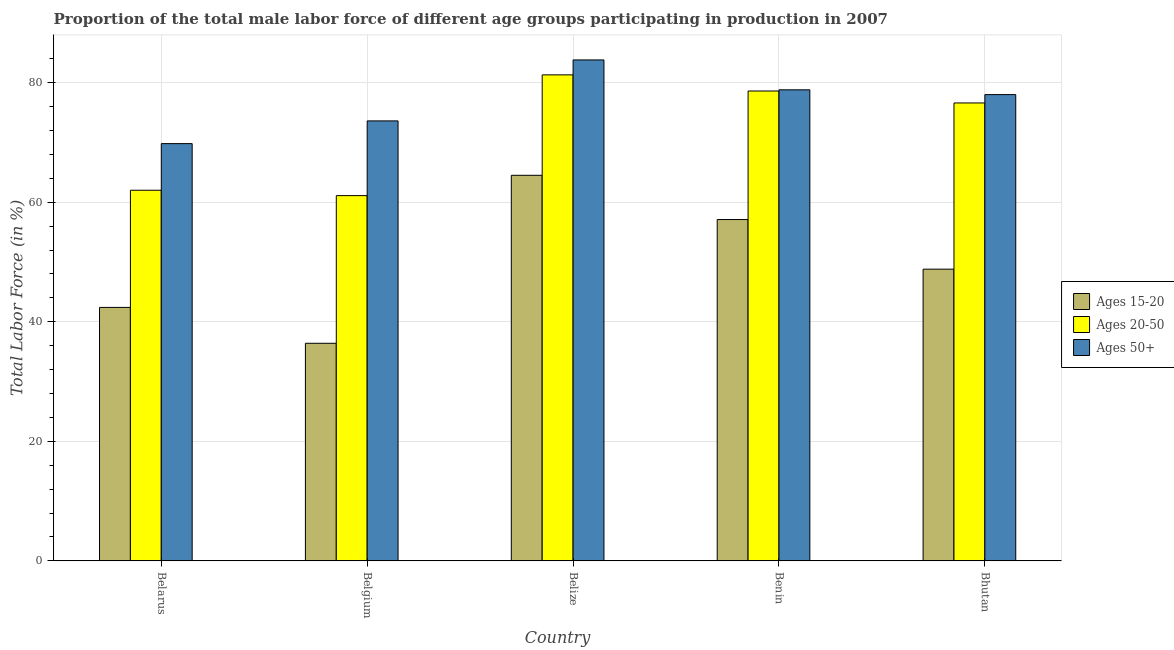How many groups of bars are there?
Ensure brevity in your answer.  5. Are the number of bars per tick equal to the number of legend labels?
Keep it short and to the point. Yes. Are the number of bars on each tick of the X-axis equal?
Your answer should be compact. Yes. How many bars are there on the 1st tick from the left?
Your response must be concise. 3. How many bars are there on the 1st tick from the right?
Make the answer very short. 3. What is the label of the 1st group of bars from the left?
Offer a very short reply. Belarus. What is the percentage of male labor force within the age group 20-50 in Belize?
Offer a terse response. 81.3. Across all countries, what is the maximum percentage of male labor force above age 50?
Offer a very short reply. 83.8. Across all countries, what is the minimum percentage of male labor force within the age group 20-50?
Offer a very short reply. 61.1. In which country was the percentage of male labor force above age 50 maximum?
Ensure brevity in your answer.  Belize. In which country was the percentage of male labor force above age 50 minimum?
Your answer should be compact. Belarus. What is the total percentage of male labor force above age 50 in the graph?
Make the answer very short. 384. What is the difference between the percentage of male labor force within the age group 15-20 in Belarus and that in Belgium?
Make the answer very short. 6. What is the difference between the percentage of male labor force within the age group 15-20 in Belgium and the percentage of male labor force within the age group 20-50 in Bhutan?
Give a very brief answer. -40.2. What is the average percentage of male labor force within the age group 20-50 per country?
Your answer should be very brief. 71.92. What is the difference between the percentage of male labor force within the age group 20-50 and percentage of male labor force above age 50 in Belgium?
Make the answer very short. -12.5. In how many countries, is the percentage of male labor force within the age group 20-50 greater than 80 %?
Give a very brief answer. 1. What is the ratio of the percentage of male labor force within the age group 20-50 in Benin to that in Bhutan?
Your answer should be very brief. 1.03. Is the percentage of male labor force within the age group 15-20 in Belgium less than that in Bhutan?
Offer a terse response. Yes. Is the difference between the percentage of male labor force above age 50 in Belarus and Bhutan greater than the difference between the percentage of male labor force within the age group 15-20 in Belarus and Bhutan?
Give a very brief answer. No. What is the difference between the highest and the second highest percentage of male labor force above age 50?
Your response must be concise. 5. What is the difference between the highest and the lowest percentage of male labor force within the age group 15-20?
Your answer should be compact. 28.1. In how many countries, is the percentage of male labor force above age 50 greater than the average percentage of male labor force above age 50 taken over all countries?
Your answer should be compact. 3. What does the 3rd bar from the left in Bhutan represents?
Give a very brief answer. Ages 50+. What does the 1st bar from the right in Bhutan represents?
Provide a short and direct response. Ages 50+. Is it the case that in every country, the sum of the percentage of male labor force within the age group 15-20 and percentage of male labor force within the age group 20-50 is greater than the percentage of male labor force above age 50?
Your answer should be very brief. Yes. How many bars are there?
Your answer should be very brief. 15. What is the difference between two consecutive major ticks on the Y-axis?
Give a very brief answer. 20. Does the graph contain any zero values?
Ensure brevity in your answer.  No. Does the graph contain grids?
Offer a very short reply. Yes. How many legend labels are there?
Make the answer very short. 3. How are the legend labels stacked?
Your answer should be very brief. Vertical. What is the title of the graph?
Keep it short and to the point. Proportion of the total male labor force of different age groups participating in production in 2007. What is the label or title of the X-axis?
Offer a terse response. Country. What is the label or title of the Y-axis?
Provide a short and direct response. Total Labor Force (in %). What is the Total Labor Force (in %) in Ages 15-20 in Belarus?
Provide a succinct answer. 42.4. What is the Total Labor Force (in %) in Ages 50+ in Belarus?
Provide a succinct answer. 69.8. What is the Total Labor Force (in %) of Ages 15-20 in Belgium?
Your answer should be very brief. 36.4. What is the Total Labor Force (in %) of Ages 20-50 in Belgium?
Provide a short and direct response. 61.1. What is the Total Labor Force (in %) of Ages 50+ in Belgium?
Make the answer very short. 73.6. What is the Total Labor Force (in %) in Ages 15-20 in Belize?
Ensure brevity in your answer.  64.5. What is the Total Labor Force (in %) in Ages 20-50 in Belize?
Your answer should be compact. 81.3. What is the Total Labor Force (in %) of Ages 50+ in Belize?
Offer a very short reply. 83.8. What is the Total Labor Force (in %) of Ages 15-20 in Benin?
Give a very brief answer. 57.1. What is the Total Labor Force (in %) of Ages 20-50 in Benin?
Offer a terse response. 78.6. What is the Total Labor Force (in %) of Ages 50+ in Benin?
Offer a terse response. 78.8. What is the Total Labor Force (in %) in Ages 15-20 in Bhutan?
Provide a succinct answer. 48.8. What is the Total Labor Force (in %) in Ages 20-50 in Bhutan?
Make the answer very short. 76.6. What is the Total Labor Force (in %) in Ages 50+ in Bhutan?
Give a very brief answer. 78. Across all countries, what is the maximum Total Labor Force (in %) in Ages 15-20?
Offer a very short reply. 64.5. Across all countries, what is the maximum Total Labor Force (in %) of Ages 20-50?
Your answer should be very brief. 81.3. Across all countries, what is the maximum Total Labor Force (in %) of Ages 50+?
Make the answer very short. 83.8. Across all countries, what is the minimum Total Labor Force (in %) in Ages 15-20?
Provide a short and direct response. 36.4. Across all countries, what is the minimum Total Labor Force (in %) in Ages 20-50?
Provide a short and direct response. 61.1. Across all countries, what is the minimum Total Labor Force (in %) of Ages 50+?
Give a very brief answer. 69.8. What is the total Total Labor Force (in %) in Ages 15-20 in the graph?
Give a very brief answer. 249.2. What is the total Total Labor Force (in %) of Ages 20-50 in the graph?
Offer a very short reply. 359.6. What is the total Total Labor Force (in %) of Ages 50+ in the graph?
Make the answer very short. 384. What is the difference between the Total Labor Force (in %) in Ages 15-20 in Belarus and that in Belgium?
Ensure brevity in your answer.  6. What is the difference between the Total Labor Force (in %) of Ages 50+ in Belarus and that in Belgium?
Your answer should be compact. -3.8. What is the difference between the Total Labor Force (in %) in Ages 15-20 in Belarus and that in Belize?
Give a very brief answer. -22.1. What is the difference between the Total Labor Force (in %) in Ages 20-50 in Belarus and that in Belize?
Offer a terse response. -19.3. What is the difference between the Total Labor Force (in %) in Ages 50+ in Belarus and that in Belize?
Make the answer very short. -14. What is the difference between the Total Labor Force (in %) in Ages 15-20 in Belarus and that in Benin?
Give a very brief answer. -14.7. What is the difference between the Total Labor Force (in %) of Ages 20-50 in Belarus and that in Benin?
Give a very brief answer. -16.6. What is the difference between the Total Labor Force (in %) of Ages 15-20 in Belarus and that in Bhutan?
Provide a short and direct response. -6.4. What is the difference between the Total Labor Force (in %) in Ages 20-50 in Belarus and that in Bhutan?
Keep it short and to the point. -14.6. What is the difference between the Total Labor Force (in %) in Ages 50+ in Belarus and that in Bhutan?
Offer a terse response. -8.2. What is the difference between the Total Labor Force (in %) of Ages 15-20 in Belgium and that in Belize?
Your answer should be compact. -28.1. What is the difference between the Total Labor Force (in %) of Ages 20-50 in Belgium and that in Belize?
Your answer should be compact. -20.2. What is the difference between the Total Labor Force (in %) in Ages 50+ in Belgium and that in Belize?
Give a very brief answer. -10.2. What is the difference between the Total Labor Force (in %) in Ages 15-20 in Belgium and that in Benin?
Offer a terse response. -20.7. What is the difference between the Total Labor Force (in %) of Ages 20-50 in Belgium and that in Benin?
Offer a very short reply. -17.5. What is the difference between the Total Labor Force (in %) in Ages 50+ in Belgium and that in Benin?
Provide a short and direct response. -5.2. What is the difference between the Total Labor Force (in %) of Ages 15-20 in Belgium and that in Bhutan?
Your answer should be compact. -12.4. What is the difference between the Total Labor Force (in %) in Ages 20-50 in Belgium and that in Bhutan?
Your answer should be very brief. -15.5. What is the difference between the Total Labor Force (in %) in Ages 15-20 in Belize and that in Benin?
Make the answer very short. 7.4. What is the difference between the Total Labor Force (in %) of Ages 50+ in Belize and that in Benin?
Your answer should be very brief. 5. What is the difference between the Total Labor Force (in %) of Ages 20-50 in Belize and that in Bhutan?
Offer a terse response. 4.7. What is the difference between the Total Labor Force (in %) of Ages 50+ in Belize and that in Bhutan?
Offer a very short reply. 5.8. What is the difference between the Total Labor Force (in %) in Ages 15-20 in Benin and that in Bhutan?
Provide a succinct answer. 8.3. What is the difference between the Total Labor Force (in %) of Ages 50+ in Benin and that in Bhutan?
Ensure brevity in your answer.  0.8. What is the difference between the Total Labor Force (in %) in Ages 15-20 in Belarus and the Total Labor Force (in %) in Ages 20-50 in Belgium?
Ensure brevity in your answer.  -18.7. What is the difference between the Total Labor Force (in %) of Ages 15-20 in Belarus and the Total Labor Force (in %) of Ages 50+ in Belgium?
Ensure brevity in your answer.  -31.2. What is the difference between the Total Labor Force (in %) of Ages 15-20 in Belarus and the Total Labor Force (in %) of Ages 20-50 in Belize?
Your response must be concise. -38.9. What is the difference between the Total Labor Force (in %) of Ages 15-20 in Belarus and the Total Labor Force (in %) of Ages 50+ in Belize?
Provide a short and direct response. -41.4. What is the difference between the Total Labor Force (in %) of Ages 20-50 in Belarus and the Total Labor Force (in %) of Ages 50+ in Belize?
Your answer should be very brief. -21.8. What is the difference between the Total Labor Force (in %) in Ages 15-20 in Belarus and the Total Labor Force (in %) in Ages 20-50 in Benin?
Your answer should be very brief. -36.2. What is the difference between the Total Labor Force (in %) of Ages 15-20 in Belarus and the Total Labor Force (in %) of Ages 50+ in Benin?
Provide a succinct answer. -36.4. What is the difference between the Total Labor Force (in %) in Ages 20-50 in Belarus and the Total Labor Force (in %) in Ages 50+ in Benin?
Offer a very short reply. -16.8. What is the difference between the Total Labor Force (in %) of Ages 15-20 in Belarus and the Total Labor Force (in %) of Ages 20-50 in Bhutan?
Ensure brevity in your answer.  -34.2. What is the difference between the Total Labor Force (in %) of Ages 15-20 in Belarus and the Total Labor Force (in %) of Ages 50+ in Bhutan?
Provide a succinct answer. -35.6. What is the difference between the Total Labor Force (in %) of Ages 20-50 in Belarus and the Total Labor Force (in %) of Ages 50+ in Bhutan?
Keep it short and to the point. -16. What is the difference between the Total Labor Force (in %) of Ages 15-20 in Belgium and the Total Labor Force (in %) of Ages 20-50 in Belize?
Keep it short and to the point. -44.9. What is the difference between the Total Labor Force (in %) of Ages 15-20 in Belgium and the Total Labor Force (in %) of Ages 50+ in Belize?
Offer a very short reply. -47.4. What is the difference between the Total Labor Force (in %) of Ages 20-50 in Belgium and the Total Labor Force (in %) of Ages 50+ in Belize?
Your response must be concise. -22.7. What is the difference between the Total Labor Force (in %) in Ages 15-20 in Belgium and the Total Labor Force (in %) in Ages 20-50 in Benin?
Ensure brevity in your answer.  -42.2. What is the difference between the Total Labor Force (in %) in Ages 15-20 in Belgium and the Total Labor Force (in %) in Ages 50+ in Benin?
Your answer should be very brief. -42.4. What is the difference between the Total Labor Force (in %) of Ages 20-50 in Belgium and the Total Labor Force (in %) of Ages 50+ in Benin?
Offer a terse response. -17.7. What is the difference between the Total Labor Force (in %) in Ages 15-20 in Belgium and the Total Labor Force (in %) in Ages 20-50 in Bhutan?
Keep it short and to the point. -40.2. What is the difference between the Total Labor Force (in %) of Ages 15-20 in Belgium and the Total Labor Force (in %) of Ages 50+ in Bhutan?
Your answer should be very brief. -41.6. What is the difference between the Total Labor Force (in %) in Ages 20-50 in Belgium and the Total Labor Force (in %) in Ages 50+ in Bhutan?
Keep it short and to the point. -16.9. What is the difference between the Total Labor Force (in %) of Ages 15-20 in Belize and the Total Labor Force (in %) of Ages 20-50 in Benin?
Ensure brevity in your answer.  -14.1. What is the difference between the Total Labor Force (in %) of Ages 15-20 in Belize and the Total Labor Force (in %) of Ages 50+ in Benin?
Your answer should be compact. -14.3. What is the difference between the Total Labor Force (in %) of Ages 20-50 in Belize and the Total Labor Force (in %) of Ages 50+ in Bhutan?
Provide a short and direct response. 3.3. What is the difference between the Total Labor Force (in %) of Ages 15-20 in Benin and the Total Labor Force (in %) of Ages 20-50 in Bhutan?
Your answer should be very brief. -19.5. What is the difference between the Total Labor Force (in %) of Ages 15-20 in Benin and the Total Labor Force (in %) of Ages 50+ in Bhutan?
Give a very brief answer. -20.9. What is the difference between the Total Labor Force (in %) of Ages 20-50 in Benin and the Total Labor Force (in %) of Ages 50+ in Bhutan?
Make the answer very short. 0.6. What is the average Total Labor Force (in %) in Ages 15-20 per country?
Your answer should be very brief. 49.84. What is the average Total Labor Force (in %) of Ages 20-50 per country?
Keep it short and to the point. 71.92. What is the average Total Labor Force (in %) in Ages 50+ per country?
Offer a very short reply. 76.8. What is the difference between the Total Labor Force (in %) in Ages 15-20 and Total Labor Force (in %) in Ages 20-50 in Belarus?
Provide a succinct answer. -19.6. What is the difference between the Total Labor Force (in %) in Ages 15-20 and Total Labor Force (in %) in Ages 50+ in Belarus?
Ensure brevity in your answer.  -27.4. What is the difference between the Total Labor Force (in %) of Ages 20-50 and Total Labor Force (in %) of Ages 50+ in Belarus?
Keep it short and to the point. -7.8. What is the difference between the Total Labor Force (in %) in Ages 15-20 and Total Labor Force (in %) in Ages 20-50 in Belgium?
Your answer should be compact. -24.7. What is the difference between the Total Labor Force (in %) in Ages 15-20 and Total Labor Force (in %) in Ages 50+ in Belgium?
Offer a very short reply. -37.2. What is the difference between the Total Labor Force (in %) of Ages 15-20 and Total Labor Force (in %) of Ages 20-50 in Belize?
Offer a very short reply. -16.8. What is the difference between the Total Labor Force (in %) of Ages 15-20 and Total Labor Force (in %) of Ages 50+ in Belize?
Ensure brevity in your answer.  -19.3. What is the difference between the Total Labor Force (in %) in Ages 20-50 and Total Labor Force (in %) in Ages 50+ in Belize?
Give a very brief answer. -2.5. What is the difference between the Total Labor Force (in %) in Ages 15-20 and Total Labor Force (in %) in Ages 20-50 in Benin?
Your response must be concise. -21.5. What is the difference between the Total Labor Force (in %) of Ages 15-20 and Total Labor Force (in %) of Ages 50+ in Benin?
Ensure brevity in your answer.  -21.7. What is the difference between the Total Labor Force (in %) of Ages 15-20 and Total Labor Force (in %) of Ages 20-50 in Bhutan?
Offer a very short reply. -27.8. What is the difference between the Total Labor Force (in %) in Ages 15-20 and Total Labor Force (in %) in Ages 50+ in Bhutan?
Offer a terse response. -29.2. What is the ratio of the Total Labor Force (in %) in Ages 15-20 in Belarus to that in Belgium?
Offer a very short reply. 1.16. What is the ratio of the Total Labor Force (in %) in Ages 20-50 in Belarus to that in Belgium?
Give a very brief answer. 1.01. What is the ratio of the Total Labor Force (in %) in Ages 50+ in Belarus to that in Belgium?
Offer a terse response. 0.95. What is the ratio of the Total Labor Force (in %) of Ages 15-20 in Belarus to that in Belize?
Provide a short and direct response. 0.66. What is the ratio of the Total Labor Force (in %) in Ages 20-50 in Belarus to that in Belize?
Make the answer very short. 0.76. What is the ratio of the Total Labor Force (in %) of Ages 50+ in Belarus to that in Belize?
Offer a terse response. 0.83. What is the ratio of the Total Labor Force (in %) in Ages 15-20 in Belarus to that in Benin?
Provide a short and direct response. 0.74. What is the ratio of the Total Labor Force (in %) in Ages 20-50 in Belarus to that in Benin?
Your answer should be compact. 0.79. What is the ratio of the Total Labor Force (in %) in Ages 50+ in Belarus to that in Benin?
Give a very brief answer. 0.89. What is the ratio of the Total Labor Force (in %) of Ages 15-20 in Belarus to that in Bhutan?
Ensure brevity in your answer.  0.87. What is the ratio of the Total Labor Force (in %) of Ages 20-50 in Belarus to that in Bhutan?
Provide a succinct answer. 0.81. What is the ratio of the Total Labor Force (in %) of Ages 50+ in Belarus to that in Bhutan?
Keep it short and to the point. 0.89. What is the ratio of the Total Labor Force (in %) of Ages 15-20 in Belgium to that in Belize?
Offer a very short reply. 0.56. What is the ratio of the Total Labor Force (in %) of Ages 20-50 in Belgium to that in Belize?
Make the answer very short. 0.75. What is the ratio of the Total Labor Force (in %) of Ages 50+ in Belgium to that in Belize?
Keep it short and to the point. 0.88. What is the ratio of the Total Labor Force (in %) in Ages 15-20 in Belgium to that in Benin?
Your answer should be very brief. 0.64. What is the ratio of the Total Labor Force (in %) in Ages 20-50 in Belgium to that in Benin?
Offer a very short reply. 0.78. What is the ratio of the Total Labor Force (in %) in Ages 50+ in Belgium to that in Benin?
Your response must be concise. 0.93. What is the ratio of the Total Labor Force (in %) in Ages 15-20 in Belgium to that in Bhutan?
Offer a very short reply. 0.75. What is the ratio of the Total Labor Force (in %) in Ages 20-50 in Belgium to that in Bhutan?
Provide a succinct answer. 0.8. What is the ratio of the Total Labor Force (in %) in Ages 50+ in Belgium to that in Bhutan?
Provide a succinct answer. 0.94. What is the ratio of the Total Labor Force (in %) in Ages 15-20 in Belize to that in Benin?
Your answer should be very brief. 1.13. What is the ratio of the Total Labor Force (in %) of Ages 20-50 in Belize to that in Benin?
Your response must be concise. 1.03. What is the ratio of the Total Labor Force (in %) in Ages 50+ in Belize to that in Benin?
Offer a very short reply. 1.06. What is the ratio of the Total Labor Force (in %) in Ages 15-20 in Belize to that in Bhutan?
Keep it short and to the point. 1.32. What is the ratio of the Total Labor Force (in %) in Ages 20-50 in Belize to that in Bhutan?
Make the answer very short. 1.06. What is the ratio of the Total Labor Force (in %) of Ages 50+ in Belize to that in Bhutan?
Ensure brevity in your answer.  1.07. What is the ratio of the Total Labor Force (in %) in Ages 15-20 in Benin to that in Bhutan?
Provide a short and direct response. 1.17. What is the ratio of the Total Labor Force (in %) in Ages 20-50 in Benin to that in Bhutan?
Your answer should be compact. 1.03. What is the ratio of the Total Labor Force (in %) of Ages 50+ in Benin to that in Bhutan?
Your answer should be very brief. 1.01. What is the difference between the highest and the lowest Total Labor Force (in %) in Ages 15-20?
Provide a succinct answer. 28.1. What is the difference between the highest and the lowest Total Labor Force (in %) in Ages 20-50?
Offer a terse response. 20.2. 